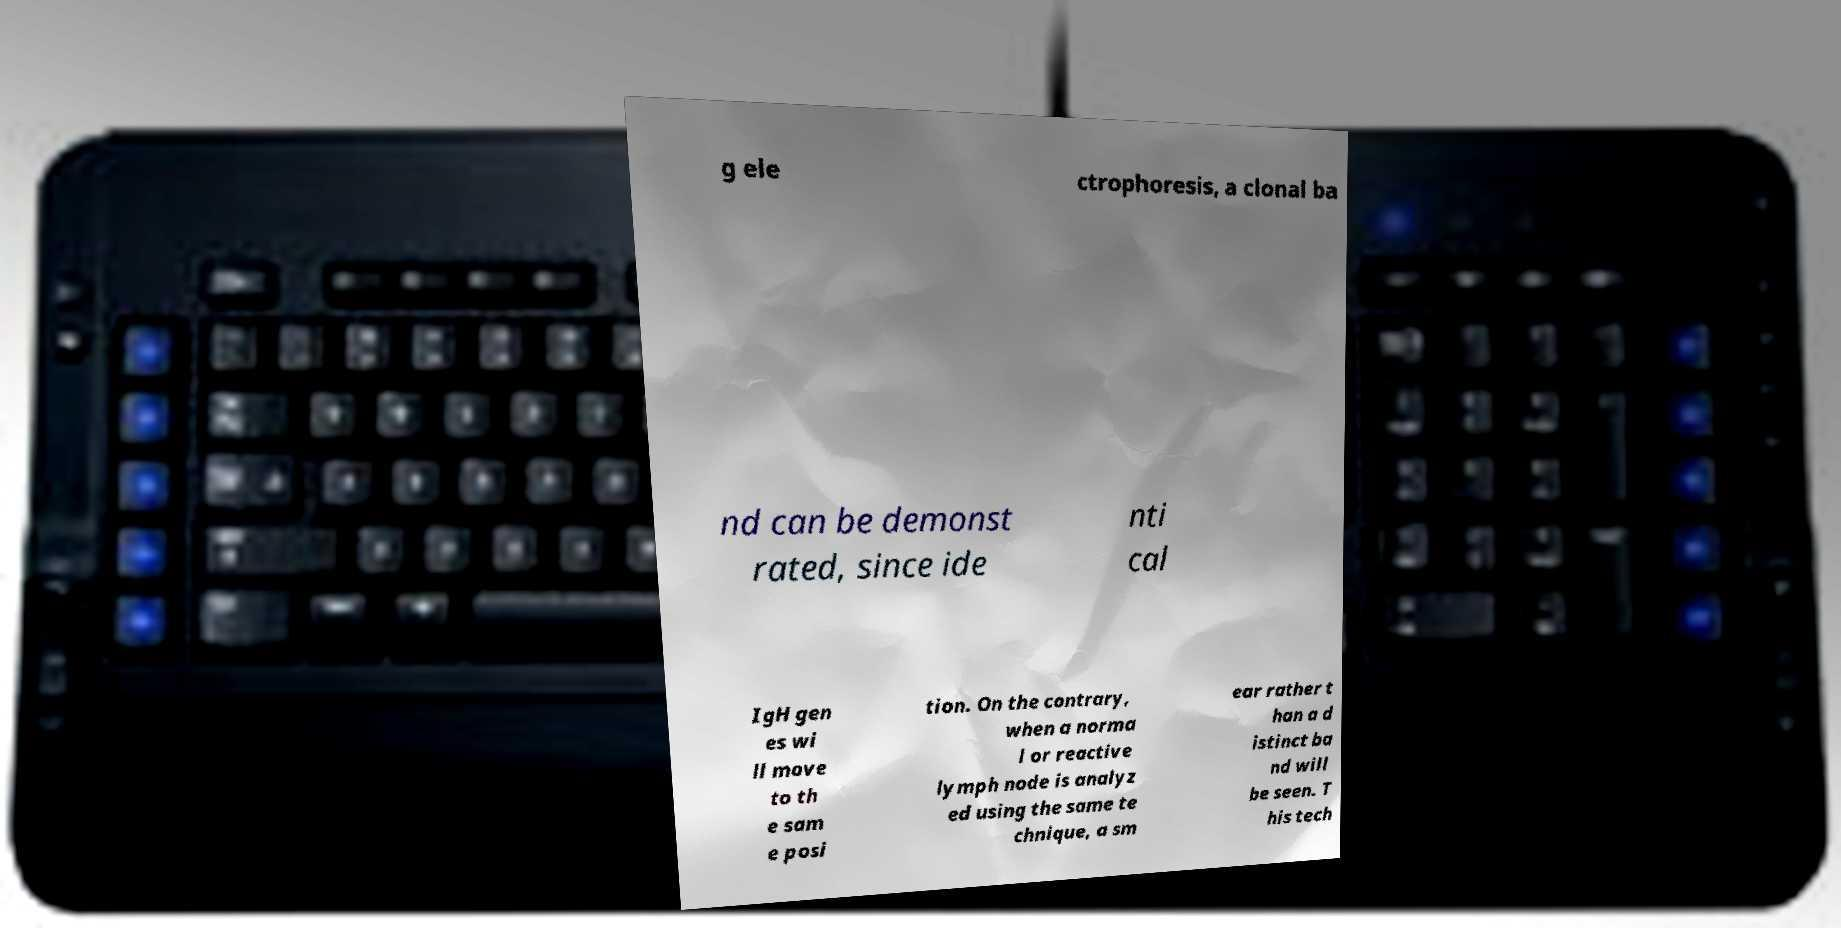For documentation purposes, I need the text within this image transcribed. Could you provide that? g ele ctrophoresis, a clonal ba nd can be demonst rated, since ide nti cal IgH gen es wi ll move to th e sam e posi tion. On the contrary, when a norma l or reactive lymph node is analyz ed using the same te chnique, a sm ear rather t han a d istinct ba nd will be seen. T his tech 